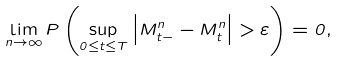Convert formula to latex. <formula><loc_0><loc_0><loc_500><loc_500>\lim _ { n \to \infty } P \left ( \sup _ { 0 \leq t \leq T } \left | M _ { t - } ^ { n } - M _ { t } ^ { n } \right | > \varepsilon \right ) = 0 ,</formula> 